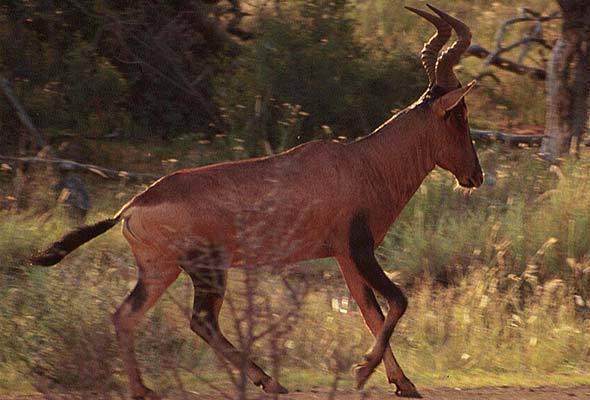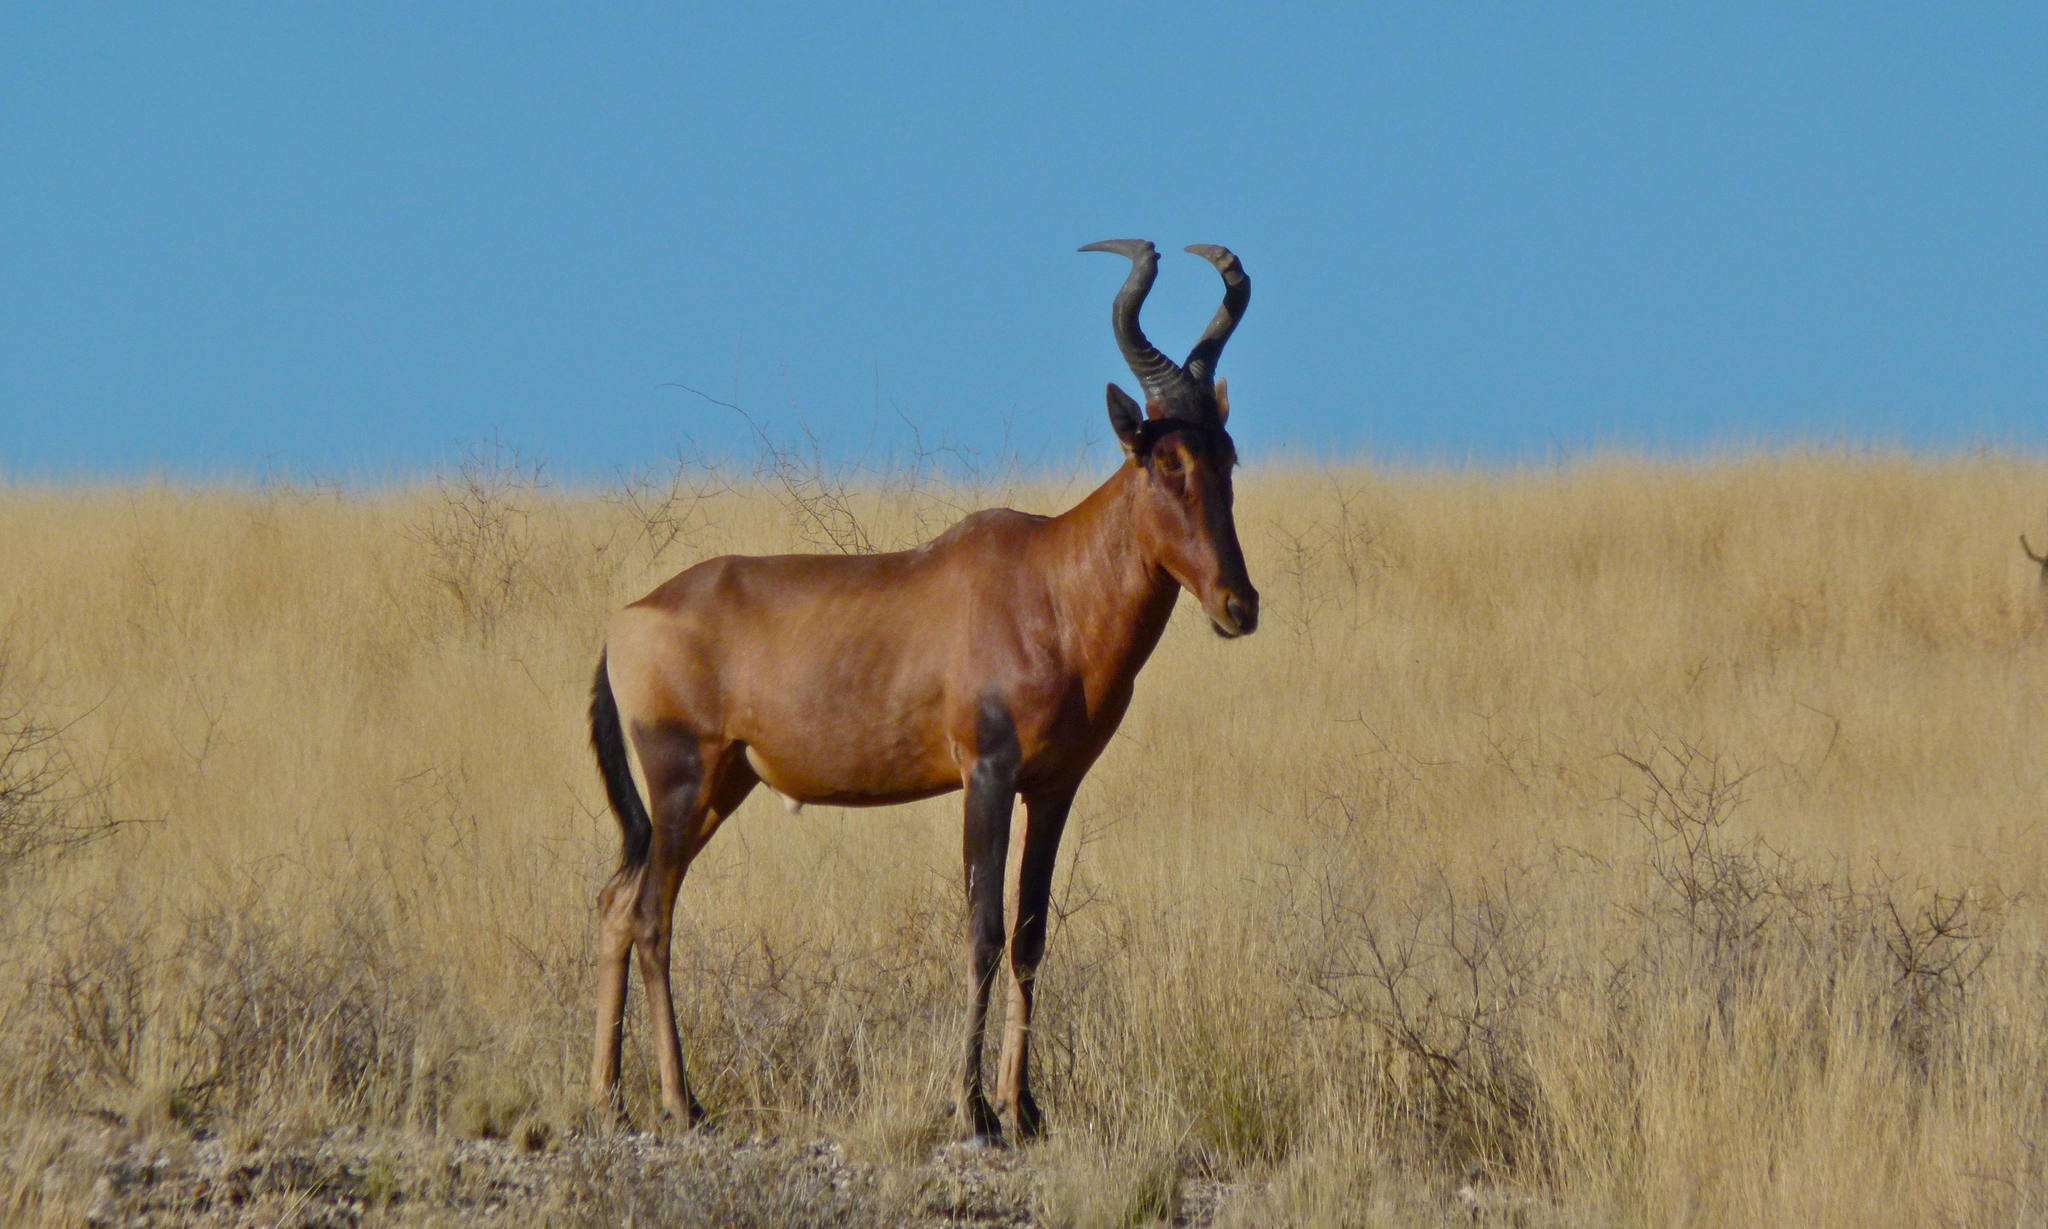The first image is the image on the left, the second image is the image on the right. For the images shown, is this caption "In one of the images there is a hunter posing behind an animal." true? Answer yes or no. No. 